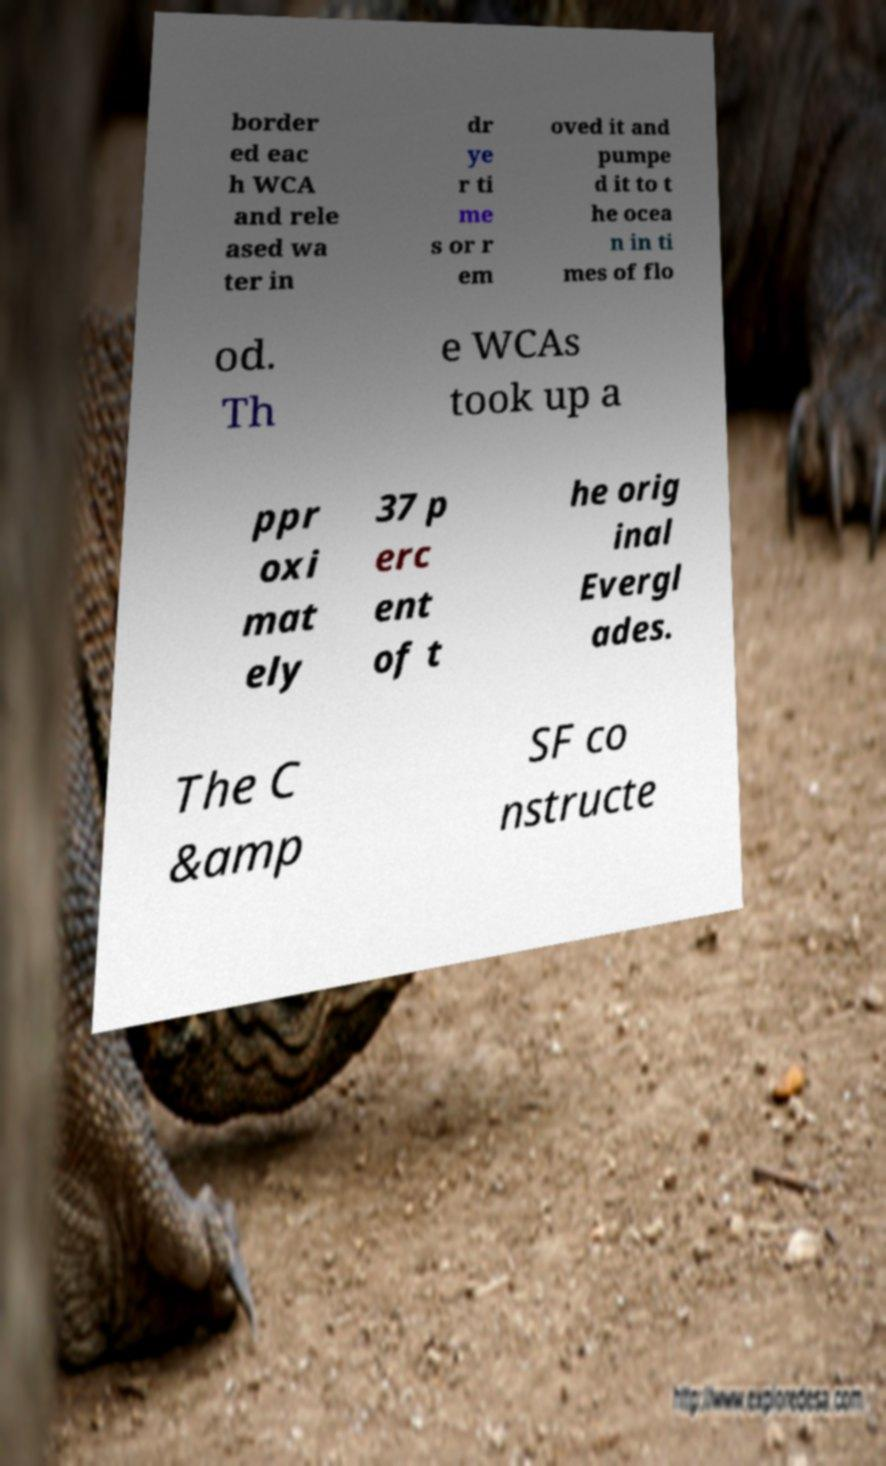Please identify and transcribe the text found in this image. border ed eac h WCA and rele ased wa ter in dr ye r ti me s or r em oved it and pumpe d it to t he ocea n in ti mes of flo od. Th e WCAs took up a ppr oxi mat ely 37 p erc ent of t he orig inal Evergl ades. The C &amp SF co nstructe 